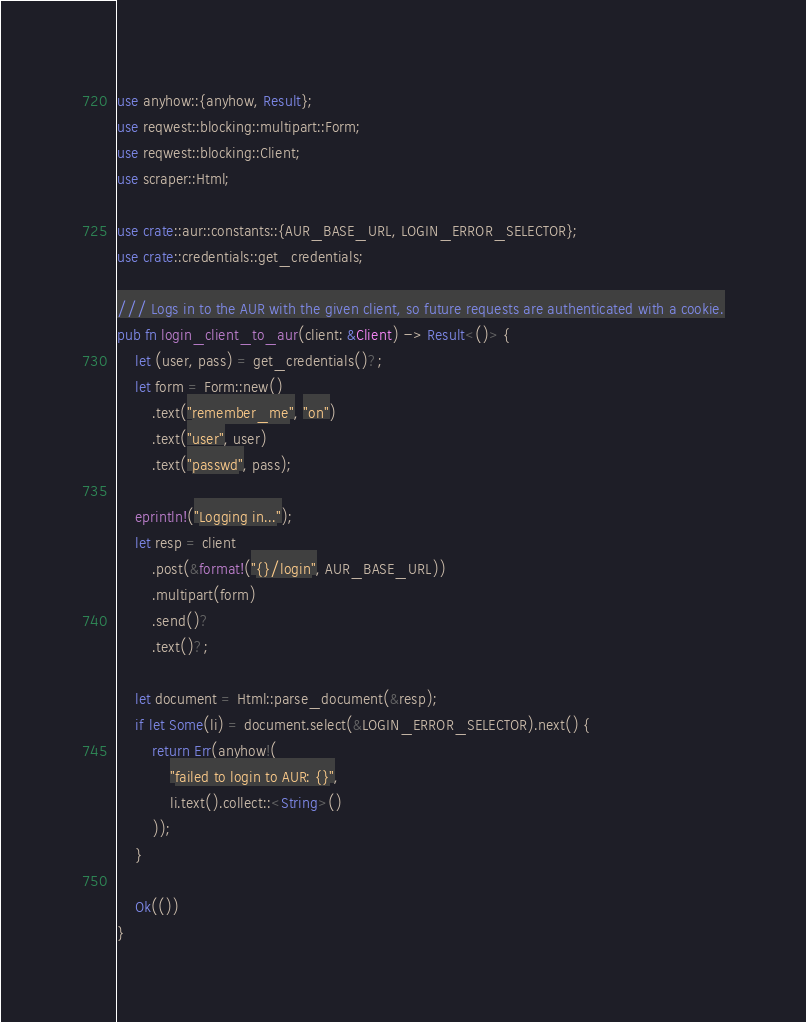Convert code to text. <code><loc_0><loc_0><loc_500><loc_500><_Rust_>use anyhow::{anyhow, Result};
use reqwest::blocking::multipart::Form;
use reqwest::blocking::Client;
use scraper::Html;

use crate::aur::constants::{AUR_BASE_URL, LOGIN_ERROR_SELECTOR};
use crate::credentials::get_credentials;

/// Logs in to the AUR with the given client, so future requests are authenticated with a cookie.
pub fn login_client_to_aur(client: &Client) -> Result<()> {
    let (user, pass) = get_credentials()?;
    let form = Form::new()
        .text("remember_me", "on")
        .text("user", user)
        .text("passwd", pass);

    eprintln!("Logging in...");
    let resp = client
        .post(&format!("{}/login", AUR_BASE_URL))
        .multipart(form)
        .send()?
        .text()?;

    let document = Html::parse_document(&resp);
    if let Some(li) = document.select(&LOGIN_ERROR_SELECTOR).next() {
        return Err(anyhow!(
            "failed to login to AUR: {}",
            li.text().collect::<String>()
        ));
    }

    Ok(())
}
</code> 